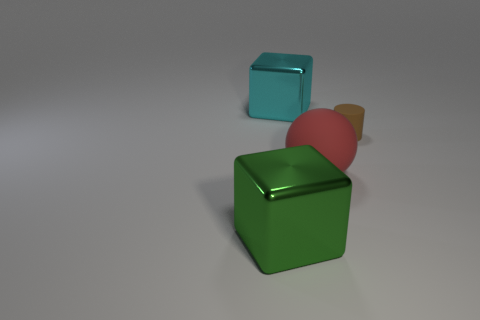How many other matte spheres are the same color as the rubber sphere?
Your response must be concise. 0. Do the matte thing behind the red rubber sphere and the large ball have the same color?
Keep it short and to the point. No. There is a object right of the red matte sphere; what is its shape?
Offer a terse response. Cylinder. Are there any cubes that are behind the metal block behind the cylinder?
Offer a terse response. No. How many cyan things are the same material as the sphere?
Offer a very short reply. 0. There is a green thing that is in front of the big cube that is on the right side of the big thing that is on the left side of the cyan block; what size is it?
Offer a very short reply. Large. There is a big cyan shiny block; what number of tiny brown cylinders are behind it?
Offer a terse response. 0. Is the number of big green things greater than the number of big yellow rubber cylinders?
Provide a short and direct response. Yes. What size is the thing that is right of the cyan block and in front of the small rubber object?
Keep it short and to the point. Large. What is the material of the cube that is in front of the big metal cube that is behind the block in front of the big ball?
Your response must be concise. Metal. 